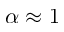<formula> <loc_0><loc_0><loc_500><loc_500>\alpha \approx 1</formula> 